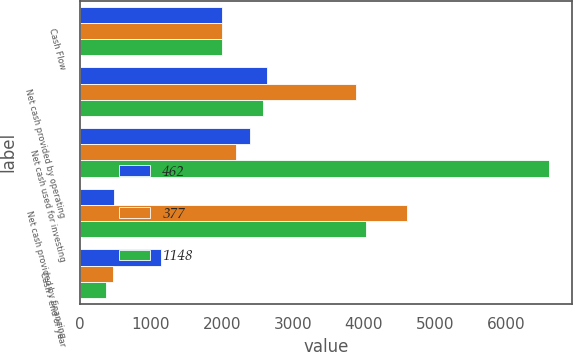Convert chart. <chart><loc_0><loc_0><loc_500><loc_500><stacked_bar_chart><ecel><fcel>Cash Flow<fcel>Net cash provided by operating<fcel>Net cash used for investing<fcel>Net cash provided by financing<fcel>Cash - end of year<nl><fcel>462<fcel>2004<fcel>2634<fcel>2401<fcel>477<fcel>1148<nl><fcel>377<fcel>2003<fcel>3896<fcel>2202.5<fcel>4608<fcel>462<nl><fcel>1148<fcel>2002<fcel>2577<fcel>6600<fcel>4037<fcel>377<nl></chart> 